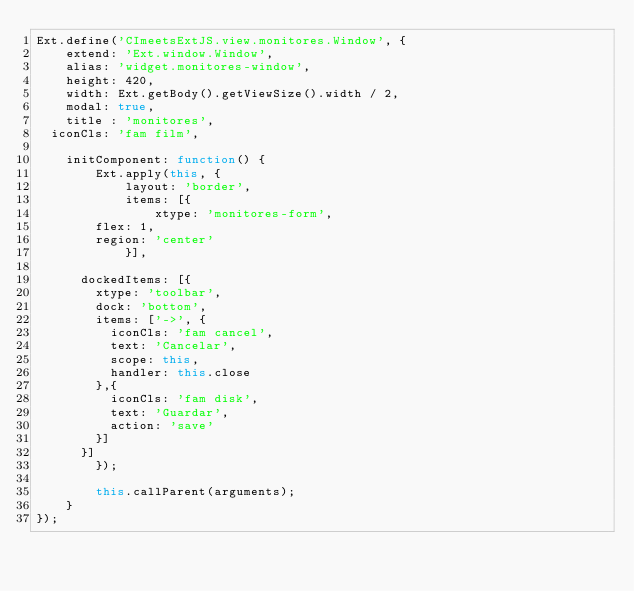Convert code to text. <code><loc_0><loc_0><loc_500><loc_500><_JavaScript_>Ext.define('CImeetsExtJS.view.monitores.Window', {
    extend: 'Ext.window.Window',
    alias: 'widget.monitores-window',
    height: 420,
    width: Ext.getBody().getViewSize().width / 2,
    modal: true,
    title : 'monitores',
	iconCls: 'fam film',

    initComponent: function() {
        Ext.apply(this, {
            layout: 'border',
            items: [{
                xtype: 'monitores-form',
				flex: 1,
				region: 'center'
            }],
			
			dockedItems: [{
				xtype: 'toolbar',
				dock: 'bottom',
				items: ['->', {
					iconCls: 'fam cancel',
					text: 'Cancelar',
					scope: this,
					handler: this.close
				},{
					iconCls: 'fam disk',
					text: 'Guardar',
					action: 'save'
				}]
			}]
        });

        this.callParent(arguments);
    }
});</code> 